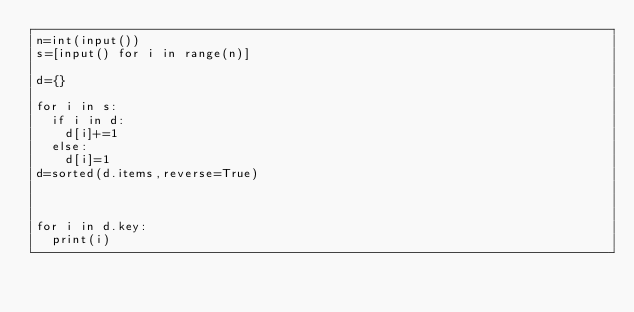Convert code to text. <code><loc_0><loc_0><loc_500><loc_500><_Python_>n=int(input())
s=[input() for i in range(n)]

d={}

for i in s:
  if i in d:
    d[i]+=1
  else:
    d[i]=1
d=sorted(d.items,reverse=True)



for i in d.key:
  print(i)
</code> 